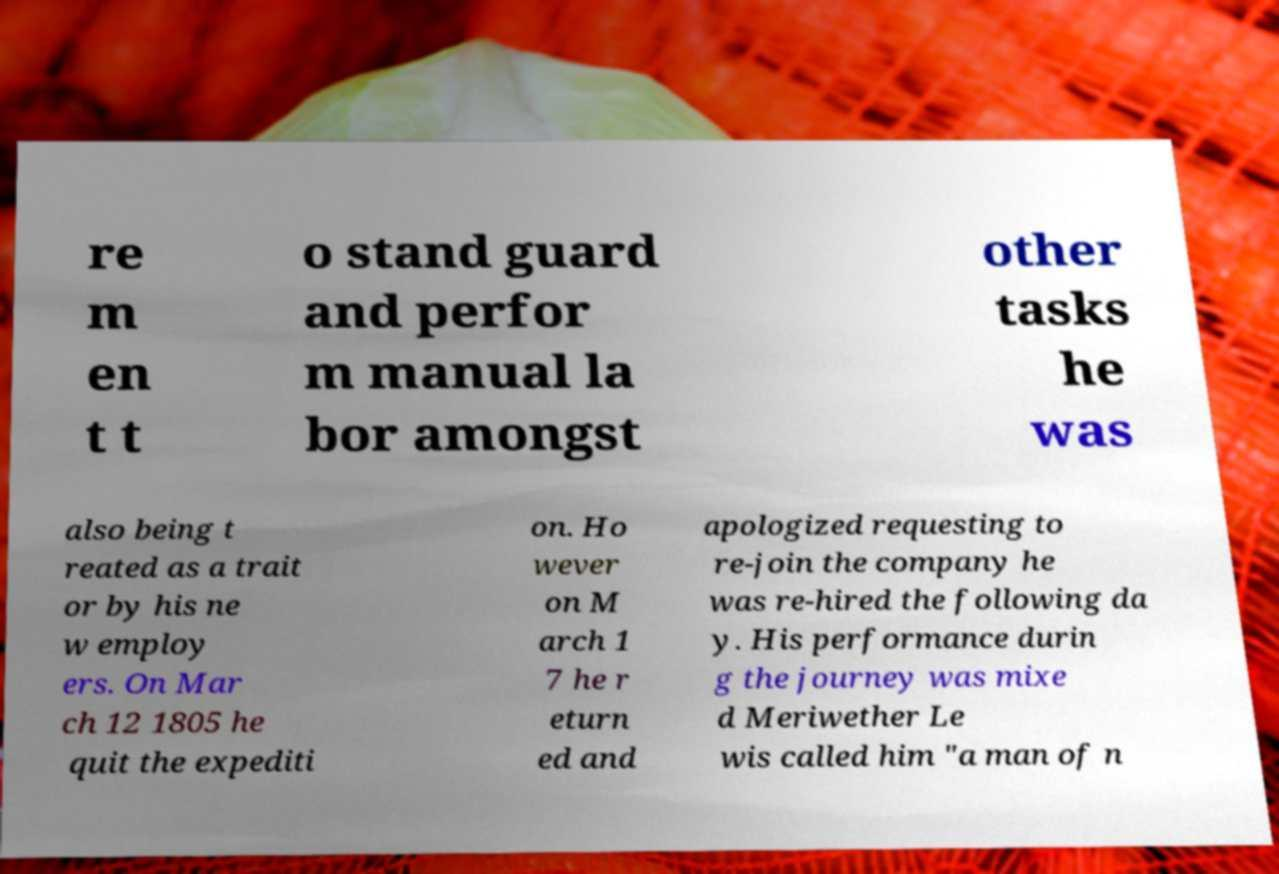For documentation purposes, I need the text within this image transcribed. Could you provide that? re m en t t o stand guard and perfor m manual la bor amongst other tasks he was also being t reated as a trait or by his ne w employ ers. On Mar ch 12 1805 he quit the expediti on. Ho wever on M arch 1 7 he r eturn ed and apologized requesting to re-join the company he was re-hired the following da y. His performance durin g the journey was mixe d Meriwether Le wis called him "a man of n 